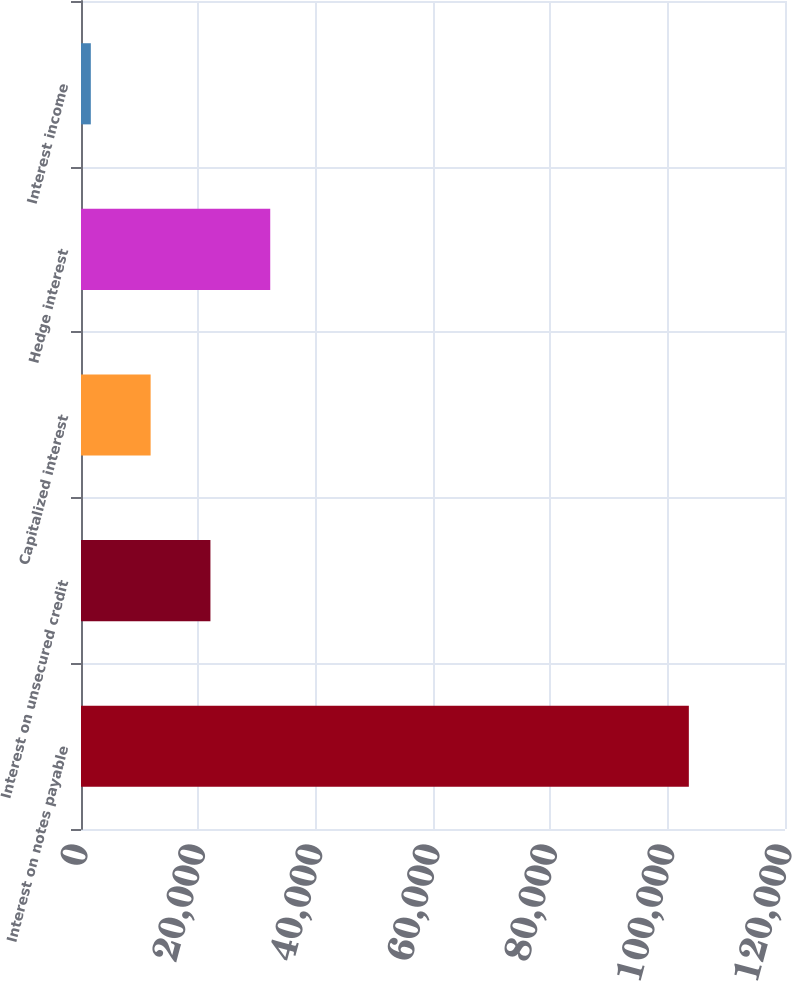Convert chart. <chart><loc_0><loc_0><loc_500><loc_500><bar_chart><fcel>Interest on notes payable<fcel>Interest on unsecured credit<fcel>Capitalized interest<fcel>Hedge interest<fcel>Interest income<nl><fcel>103610<fcel>22062<fcel>11868.5<fcel>32255.5<fcel>1675<nl></chart> 